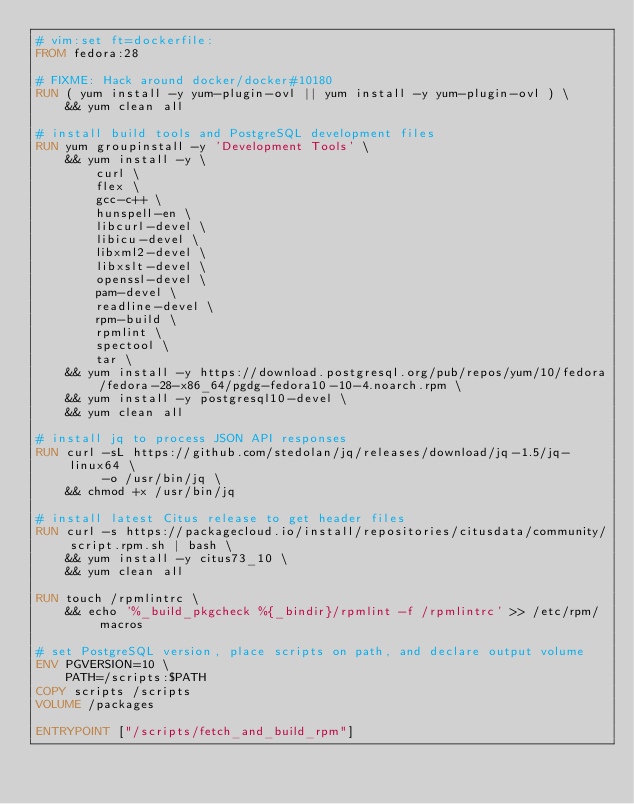<code> <loc_0><loc_0><loc_500><loc_500><_Dockerfile_># vim:set ft=dockerfile:
FROM fedora:28

# FIXME: Hack around docker/docker#10180
RUN ( yum install -y yum-plugin-ovl || yum install -y yum-plugin-ovl ) \
    && yum clean all

# install build tools and PostgreSQL development files
RUN yum groupinstall -y 'Development Tools' \
    && yum install -y \
        curl \
        flex \
        gcc-c++ \
        hunspell-en \
        libcurl-devel \
        libicu-devel \
        libxml2-devel \
        libxslt-devel \
        openssl-devel \
        pam-devel \
        readline-devel \
        rpm-build \
        rpmlint \
        spectool \
        tar \
    && yum install -y https://download.postgresql.org/pub/repos/yum/10/fedora/fedora-28-x86_64/pgdg-fedora10-10-4.noarch.rpm \
    && yum install -y postgresql10-devel \
    && yum clean all

# install jq to process JSON API responses
RUN curl -sL https://github.com/stedolan/jq/releases/download/jq-1.5/jq-linux64 \
         -o /usr/bin/jq \
    && chmod +x /usr/bin/jq

# install latest Citus release to get header files
RUN curl -s https://packagecloud.io/install/repositories/citusdata/community/script.rpm.sh | bash \
    && yum install -y citus73_10 \
    && yum clean all

RUN touch /rpmlintrc \
    && echo '%_build_pkgcheck %{_bindir}/rpmlint -f /rpmlintrc' >> /etc/rpm/macros

# set PostgreSQL version, place scripts on path, and declare output volume
ENV PGVERSION=10 \
    PATH=/scripts:$PATH
COPY scripts /scripts
VOLUME /packages

ENTRYPOINT ["/scripts/fetch_and_build_rpm"]
</code> 